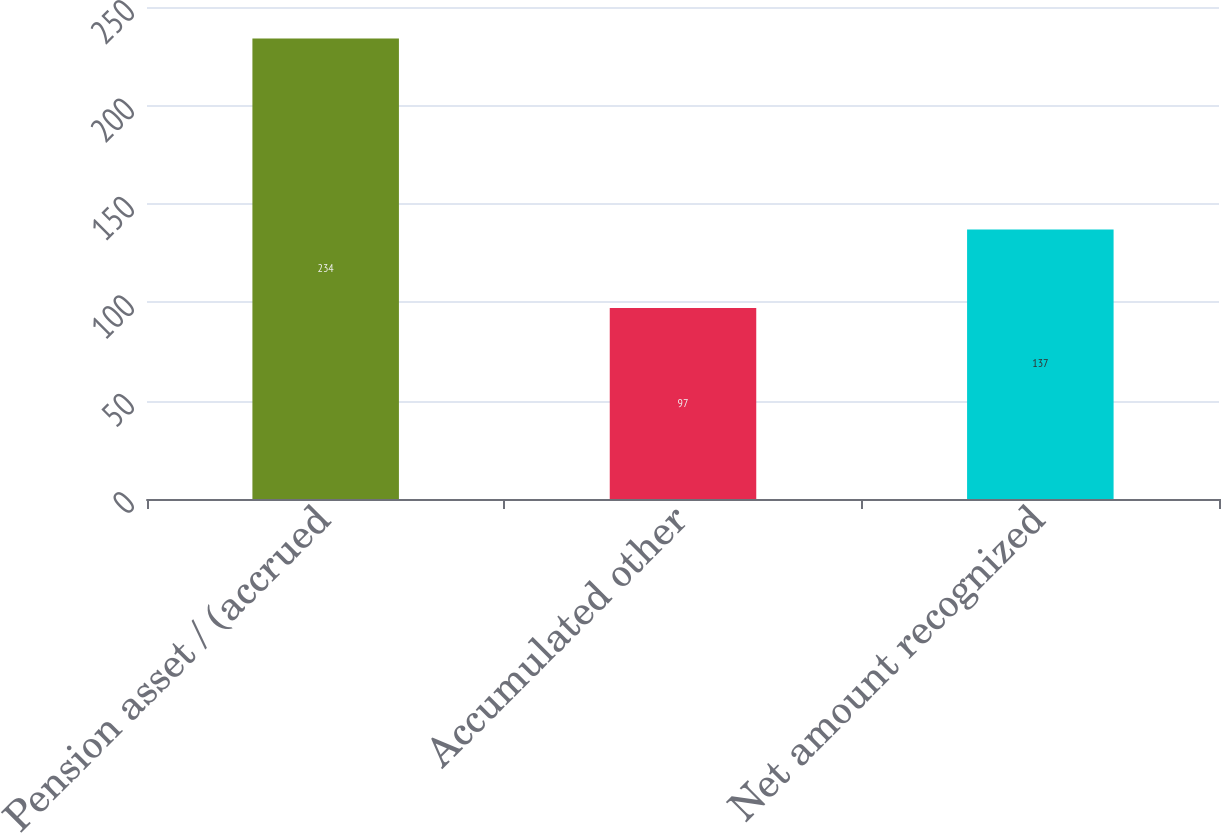Convert chart to OTSL. <chart><loc_0><loc_0><loc_500><loc_500><bar_chart><fcel>Pension asset / (accrued<fcel>Accumulated other<fcel>Net amount recognized<nl><fcel>234<fcel>97<fcel>137<nl></chart> 